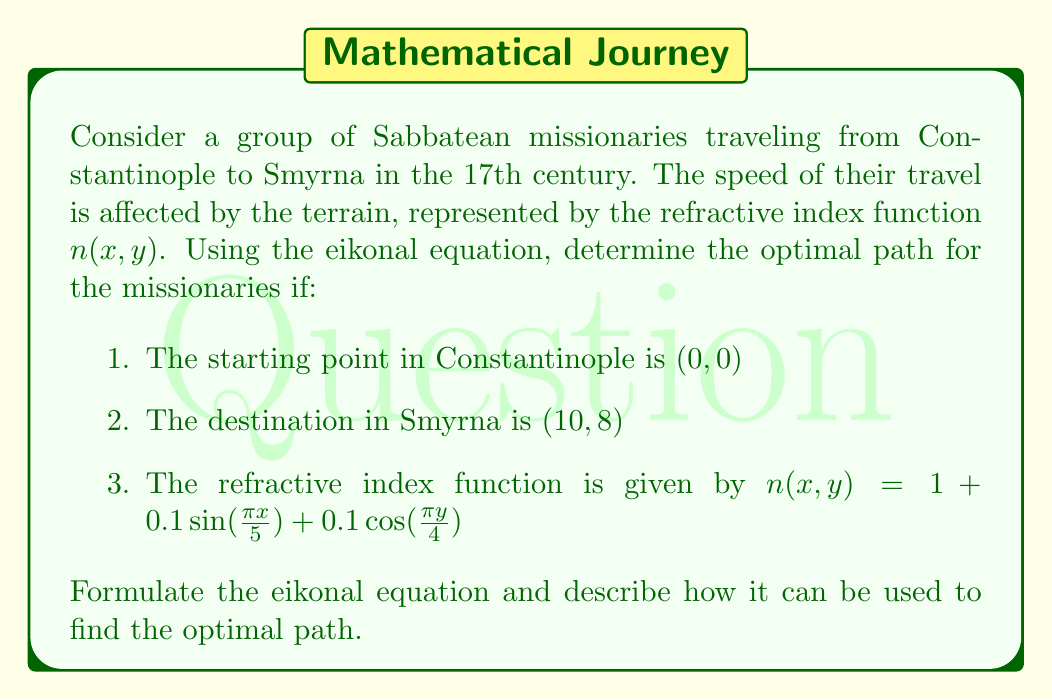What is the answer to this math problem? To solve this problem, we need to understand and apply the eikonal equation in the context of Sabbatean missionary travel. Let's break it down step-by-step:

1) The eikonal equation is given by:

   $$|\nabla T(x,y)| = n(x,y)$$

   where $T(x,y)$ is the travel time function and $n(x,y)$ is the refractive index.

2) In our case, $n(x,y) = 1 + 0.1\sin(\frac{\pi x}{5}) + 0.1\cos(\frac{\pi y}{4})$

3) The eikonal equation can be written in component form as:

   $$\sqrt{(\frac{\partial T}{\partial x})^2 + (\frac{\partial T}{\partial y})^2} = 1 + 0.1\sin(\frac{\pi x}{5}) + 0.1\cos(\frac{\pi y}{4})$$

4) To find the optimal path, we need to solve this partial differential equation with the boundary conditions:
   
   $T(0,0) = 0$ (starting point)
   $T(10,8)$ = minimum travel time (destination)

5) The solution to this equation will give us a surface $T(x,y)$ representing the travel time from the starting point to any point $(x,y)$.

6) The optimal path can then be found by tracing the gradient of $T(x,y)$ from the destination back to the starting point. This path will always be perpendicular to the level curves of $T(x,y)$.

7) Mathematically, the path $\mathbf{r}(s) = (x(s), y(s))$ satisfies:

   $$\frac{d\mathbf{r}}{ds} = \frac{\nabla T}{|\nabla T|}$$

8) Solving this equation numerically (e.g., using the Fast Marching Method) would give us the optimal path for the Sabbatean missionaries.

This approach takes into account the varying terrain (represented by the refractive index) and ensures that the missionaries take the path that minimizes their total travel time, which is crucial for the efficient spread of Sabbatean teachings.
Answer: The optimal path for the Sabbatean missionaries can be determined by solving the eikonal equation:

$$\sqrt{(\frac{\partial T}{\partial x})^2 + (\frac{\partial T}{\partial y})^2} = 1 + 0.1\sin(\frac{\pi x}{5}) + 0.1\cos(\frac{\pi y}{4})$$

with boundary conditions $T(0,0) = 0$ and $T(10,8)$ minimized. The path is then found by tracing the gradient of the solution $T(x,y)$ from $(10,8)$ to $(0,0)$. 